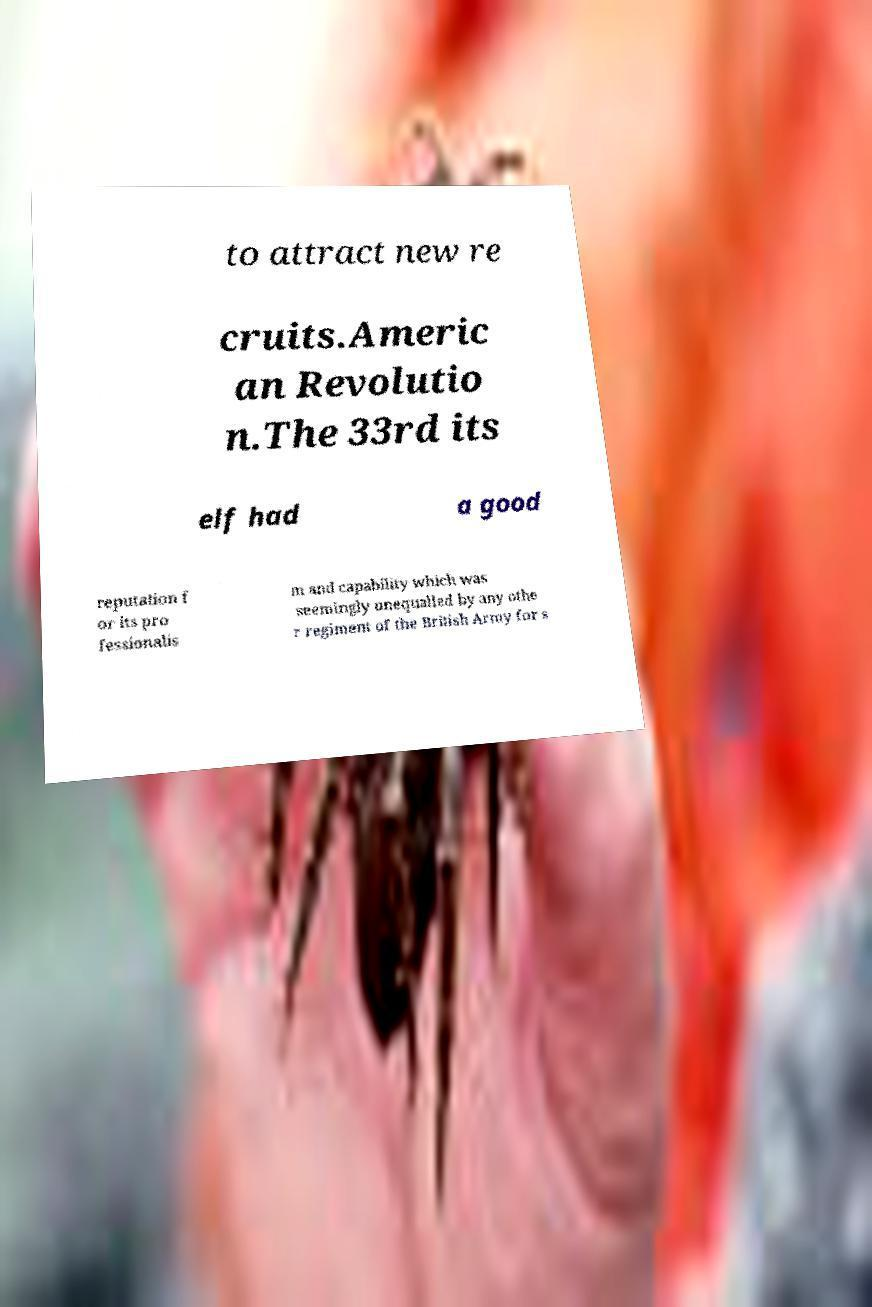Can you accurately transcribe the text from the provided image for me? to attract new re cruits.Americ an Revolutio n.The 33rd its elf had a good reputation f or its pro fessionalis m and capability which was seemingly unequalled by any othe r regiment of the British Army for s 